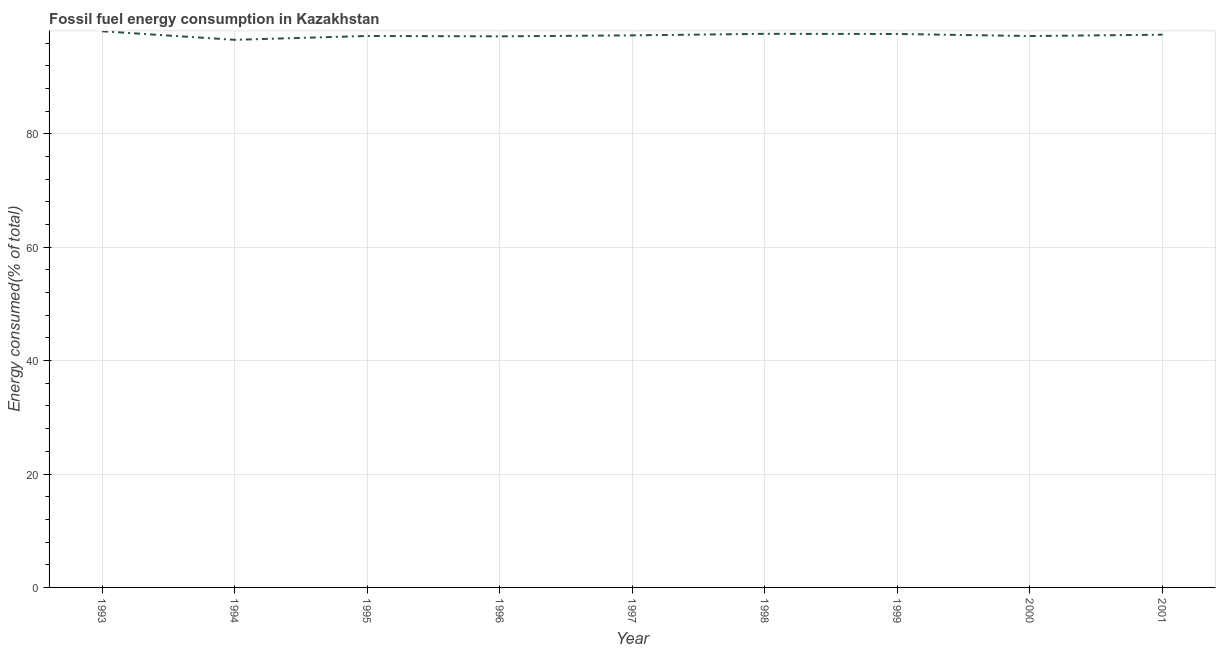What is the fossil fuel energy consumption in 2001?
Your answer should be very brief. 97.48. Across all years, what is the maximum fossil fuel energy consumption?
Make the answer very short. 98.09. Across all years, what is the minimum fossil fuel energy consumption?
Keep it short and to the point. 96.58. In which year was the fossil fuel energy consumption maximum?
Give a very brief answer. 1993. In which year was the fossil fuel energy consumption minimum?
Make the answer very short. 1994. What is the sum of the fossil fuel energy consumption?
Make the answer very short. 876.49. What is the difference between the fossil fuel energy consumption in 1995 and 2000?
Your answer should be compact. 0.01. What is the average fossil fuel energy consumption per year?
Your answer should be compact. 97.39. What is the median fossil fuel energy consumption?
Give a very brief answer. 97.37. What is the ratio of the fossil fuel energy consumption in 1993 to that in 1998?
Keep it short and to the point. 1. What is the difference between the highest and the second highest fossil fuel energy consumption?
Offer a very short reply. 0.46. Is the sum of the fossil fuel energy consumption in 1993 and 2001 greater than the maximum fossil fuel energy consumption across all years?
Offer a very short reply. Yes. What is the difference between the highest and the lowest fossil fuel energy consumption?
Your answer should be very brief. 1.51. Does the fossil fuel energy consumption monotonically increase over the years?
Make the answer very short. No. How many lines are there?
Provide a succinct answer. 1. Are the values on the major ticks of Y-axis written in scientific E-notation?
Offer a terse response. No. Does the graph contain any zero values?
Your answer should be compact. No. What is the title of the graph?
Give a very brief answer. Fossil fuel energy consumption in Kazakhstan. What is the label or title of the X-axis?
Provide a succinct answer. Year. What is the label or title of the Y-axis?
Make the answer very short. Energy consumed(% of total). What is the Energy consumed(% of total) in 1993?
Offer a terse response. 98.09. What is the Energy consumed(% of total) in 1994?
Offer a terse response. 96.58. What is the Energy consumed(% of total) of 1995?
Give a very brief answer. 97.26. What is the Energy consumed(% of total) of 1996?
Your answer should be compact. 97.19. What is the Energy consumed(% of total) in 1997?
Your response must be concise. 97.37. What is the Energy consumed(% of total) in 1998?
Your answer should be compact. 97.64. What is the Energy consumed(% of total) of 1999?
Your answer should be very brief. 97.61. What is the Energy consumed(% of total) of 2000?
Offer a very short reply. 97.25. What is the Energy consumed(% of total) in 2001?
Offer a very short reply. 97.48. What is the difference between the Energy consumed(% of total) in 1993 and 1994?
Give a very brief answer. 1.51. What is the difference between the Energy consumed(% of total) in 1993 and 1995?
Offer a very short reply. 0.83. What is the difference between the Energy consumed(% of total) in 1993 and 1996?
Offer a terse response. 0.9. What is the difference between the Energy consumed(% of total) in 1993 and 1997?
Give a very brief answer. 0.72. What is the difference between the Energy consumed(% of total) in 1993 and 1998?
Your answer should be very brief. 0.46. What is the difference between the Energy consumed(% of total) in 1993 and 1999?
Give a very brief answer. 0.48. What is the difference between the Energy consumed(% of total) in 1993 and 2000?
Offer a very short reply. 0.84. What is the difference between the Energy consumed(% of total) in 1993 and 2001?
Give a very brief answer. 0.61. What is the difference between the Energy consumed(% of total) in 1994 and 1995?
Your response must be concise. -0.68. What is the difference between the Energy consumed(% of total) in 1994 and 1996?
Ensure brevity in your answer.  -0.61. What is the difference between the Energy consumed(% of total) in 1994 and 1997?
Give a very brief answer. -0.79. What is the difference between the Energy consumed(% of total) in 1994 and 1998?
Offer a very short reply. -1.06. What is the difference between the Energy consumed(% of total) in 1994 and 1999?
Your answer should be very brief. -1.03. What is the difference between the Energy consumed(% of total) in 1994 and 2000?
Provide a succinct answer. -0.67. What is the difference between the Energy consumed(% of total) in 1994 and 2001?
Make the answer very short. -0.9. What is the difference between the Energy consumed(% of total) in 1995 and 1996?
Provide a short and direct response. 0.07. What is the difference between the Energy consumed(% of total) in 1995 and 1997?
Make the answer very short. -0.11. What is the difference between the Energy consumed(% of total) in 1995 and 1998?
Give a very brief answer. -0.38. What is the difference between the Energy consumed(% of total) in 1995 and 1999?
Ensure brevity in your answer.  -0.35. What is the difference between the Energy consumed(% of total) in 1995 and 2000?
Your answer should be very brief. 0.01. What is the difference between the Energy consumed(% of total) in 1995 and 2001?
Your answer should be compact. -0.22. What is the difference between the Energy consumed(% of total) in 1996 and 1997?
Offer a very short reply. -0.18. What is the difference between the Energy consumed(% of total) in 1996 and 1998?
Your answer should be very brief. -0.44. What is the difference between the Energy consumed(% of total) in 1996 and 1999?
Provide a succinct answer. -0.42. What is the difference between the Energy consumed(% of total) in 1996 and 2000?
Your answer should be compact. -0.06. What is the difference between the Energy consumed(% of total) in 1996 and 2001?
Provide a succinct answer. -0.29. What is the difference between the Energy consumed(% of total) in 1997 and 1998?
Provide a short and direct response. -0.27. What is the difference between the Energy consumed(% of total) in 1997 and 1999?
Provide a succinct answer. -0.24. What is the difference between the Energy consumed(% of total) in 1997 and 2000?
Your response must be concise. 0.12. What is the difference between the Energy consumed(% of total) in 1997 and 2001?
Provide a succinct answer. -0.11. What is the difference between the Energy consumed(% of total) in 1998 and 1999?
Provide a succinct answer. 0.03. What is the difference between the Energy consumed(% of total) in 1998 and 2000?
Keep it short and to the point. 0.39. What is the difference between the Energy consumed(% of total) in 1998 and 2001?
Provide a succinct answer. 0.15. What is the difference between the Energy consumed(% of total) in 1999 and 2000?
Make the answer very short. 0.36. What is the difference between the Energy consumed(% of total) in 1999 and 2001?
Offer a very short reply. 0.13. What is the difference between the Energy consumed(% of total) in 2000 and 2001?
Your answer should be very brief. -0.23. What is the ratio of the Energy consumed(% of total) in 1993 to that in 1997?
Offer a very short reply. 1.01. What is the ratio of the Energy consumed(% of total) in 1993 to that in 2000?
Make the answer very short. 1.01. What is the ratio of the Energy consumed(% of total) in 1994 to that in 1995?
Give a very brief answer. 0.99. What is the ratio of the Energy consumed(% of total) in 1994 to that in 1996?
Provide a short and direct response. 0.99. What is the ratio of the Energy consumed(% of total) in 1994 to that in 1997?
Offer a terse response. 0.99. What is the ratio of the Energy consumed(% of total) in 1994 to that in 1998?
Provide a short and direct response. 0.99. What is the ratio of the Energy consumed(% of total) in 1994 to that in 2000?
Offer a very short reply. 0.99. What is the ratio of the Energy consumed(% of total) in 1994 to that in 2001?
Offer a very short reply. 0.99. What is the ratio of the Energy consumed(% of total) in 1995 to that in 1996?
Your answer should be very brief. 1. What is the ratio of the Energy consumed(% of total) in 1995 to that in 1997?
Provide a short and direct response. 1. What is the ratio of the Energy consumed(% of total) in 1995 to that in 1999?
Provide a succinct answer. 1. What is the ratio of the Energy consumed(% of total) in 1995 to that in 2000?
Give a very brief answer. 1. What is the ratio of the Energy consumed(% of total) in 1996 to that in 1997?
Provide a short and direct response. 1. What is the ratio of the Energy consumed(% of total) in 1996 to that in 1998?
Keep it short and to the point. 0.99. What is the ratio of the Energy consumed(% of total) in 1996 to that in 1999?
Give a very brief answer. 1. What is the ratio of the Energy consumed(% of total) in 1996 to that in 2000?
Offer a terse response. 1. What is the ratio of the Energy consumed(% of total) in 1997 to that in 1998?
Your response must be concise. 1. What is the ratio of the Energy consumed(% of total) in 1997 to that in 2000?
Make the answer very short. 1. What is the ratio of the Energy consumed(% of total) in 1997 to that in 2001?
Make the answer very short. 1. What is the ratio of the Energy consumed(% of total) in 1998 to that in 1999?
Make the answer very short. 1. What is the ratio of the Energy consumed(% of total) in 1999 to that in 2001?
Your response must be concise. 1. What is the ratio of the Energy consumed(% of total) in 2000 to that in 2001?
Give a very brief answer. 1. 